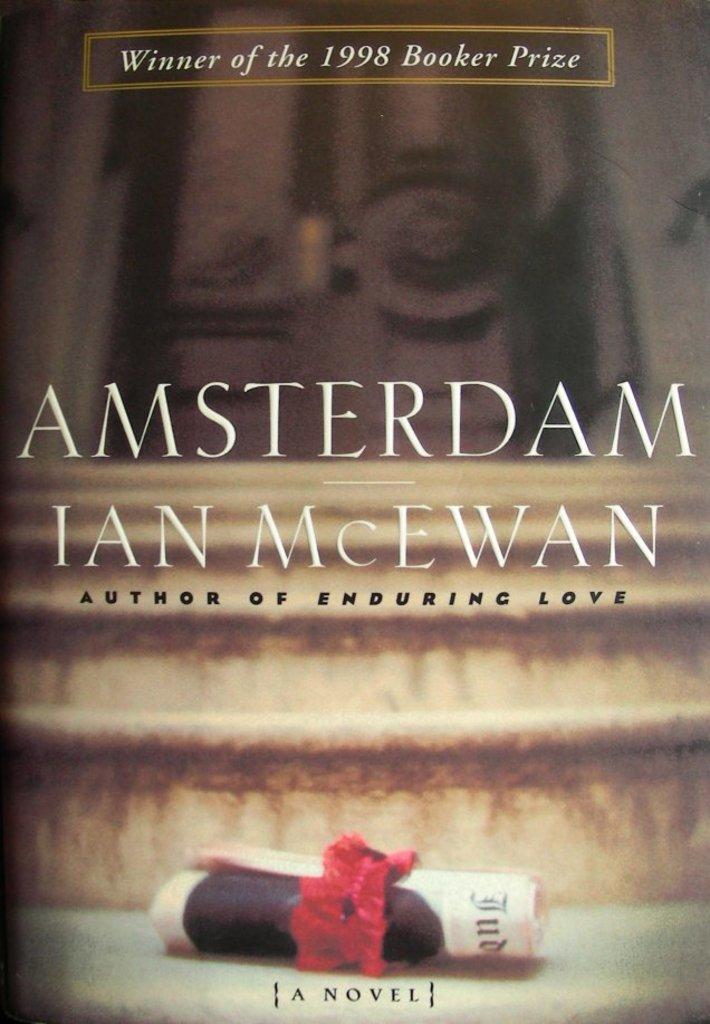Please provide a concise description of this image. This is the poster where we can see some text written on it. Background of the image, paper roll is there on the stairs and one door is there. 